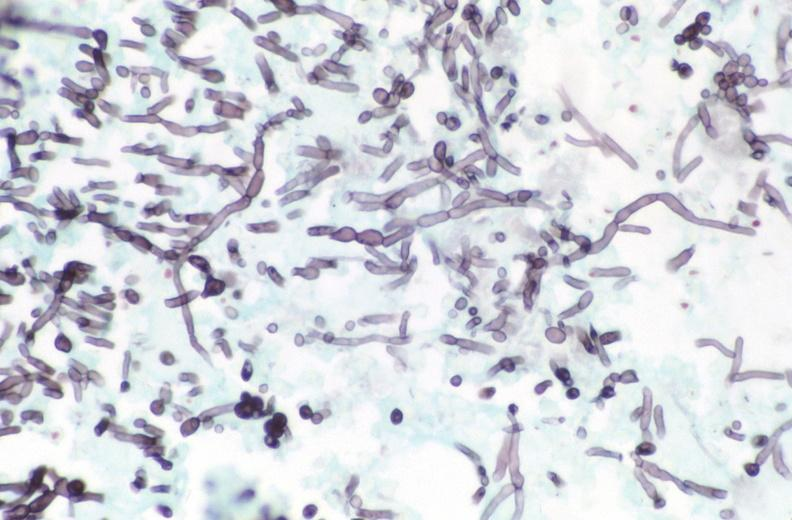does endocrine show esohagus, candida?
Answer the question using a single word or phrase. No 